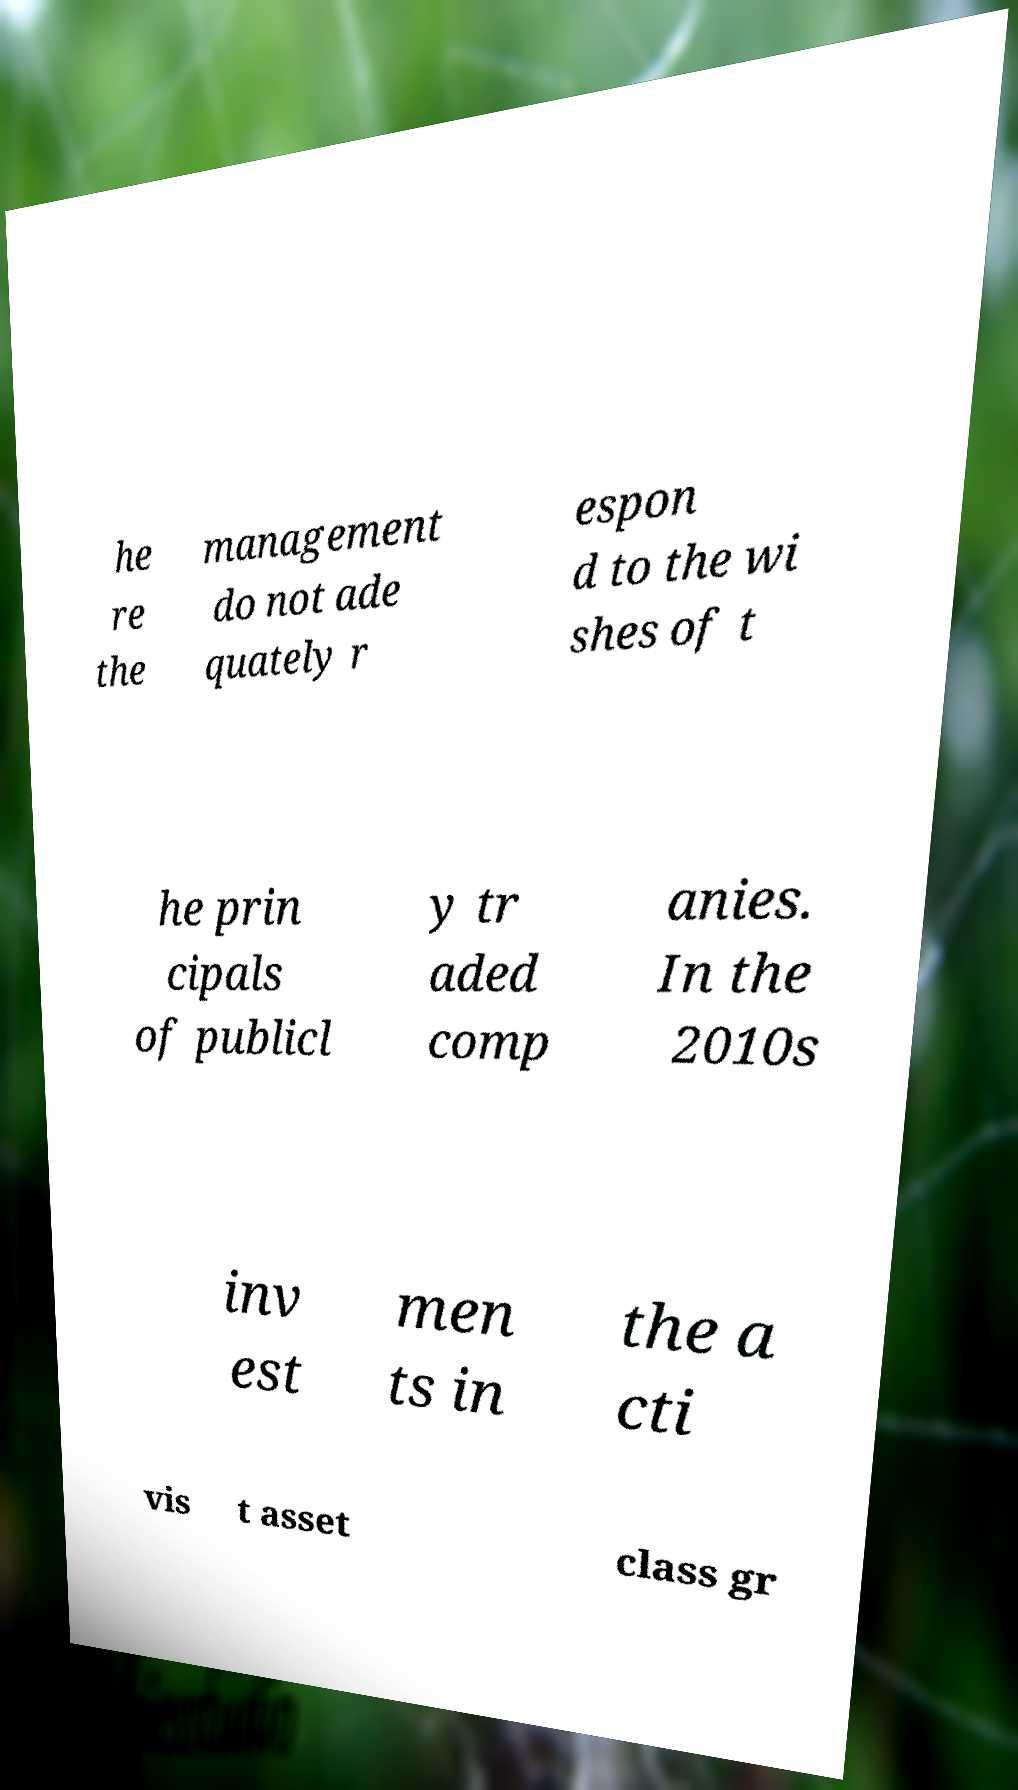For documentation purposes, I need the text within this image transcribed. Could you provide that? he re the management do not ade quately r espon d to the wi shes of t he prin cipals of publicl y tr aded comp anies. In the 2010s inv est men ts in the a cti vis t asset class gr 